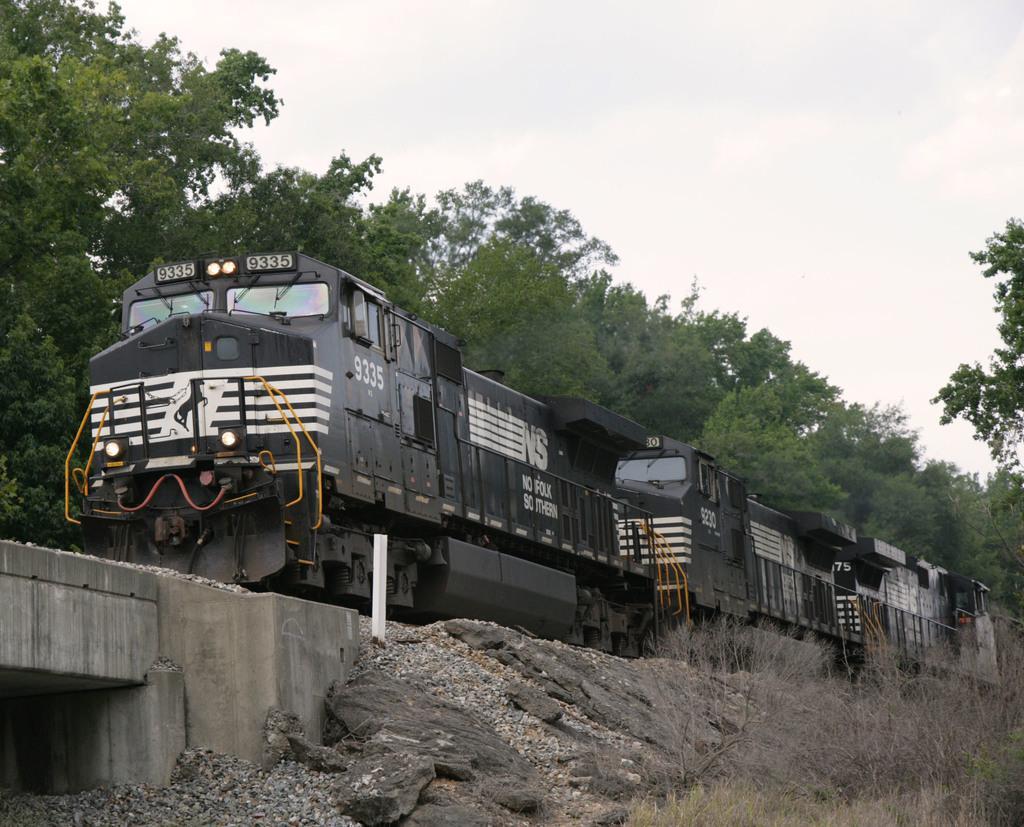Please provide a concise description of this image. In this picture we can see a train. On the left side of the image, there is a bridge. On the right side of the image, there is grass. Behind the train there are trees and the cloudy sky. 